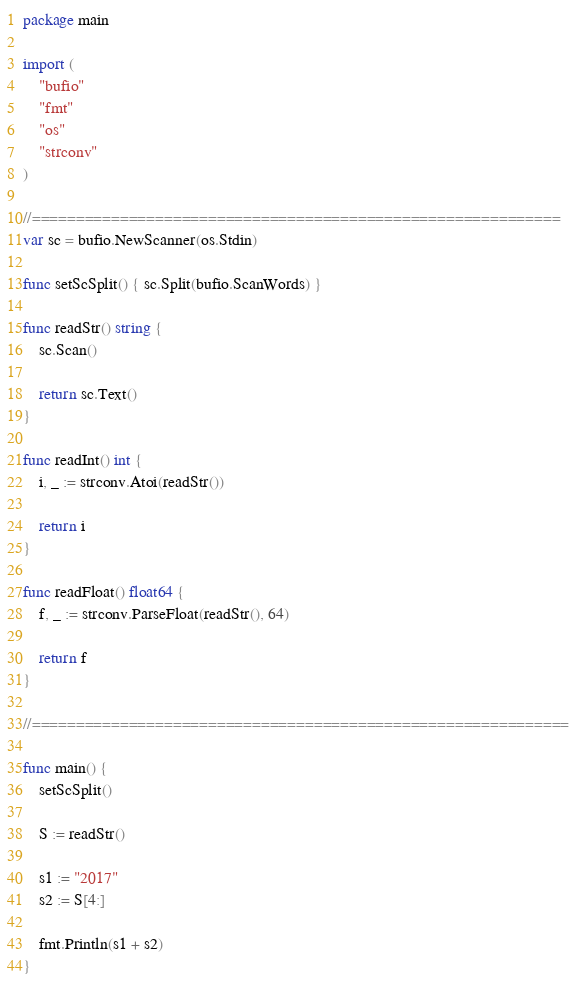Convert code to text. <code><loc_0><loc_0><loc_500><loc_500><_Go_>package main

import (
	"bufio"
	"fmt"
	"os"
	"strconv"
)

//============================================================
var sc = bufio.NewScanner(os.Stdin)

func setScSplit() { sc.Split(bufio.ScanWords) }

func readStr() string {
	sc.Scan()

	return sc.Text()
}

func readInt() int {
	i, _ := strconv.Atoi(readStr())

	return i
}

func readFloat() float64 {
	f, _ := strconv.ParseFloat(readStr(), 64)

	return f
}

//=============================================================

func main() {
	setScSplit()

	S := readStr()

	s1 := "2017"
	s2 := S[4:]

	fmt.Println(s1 + s2)
}</code> 